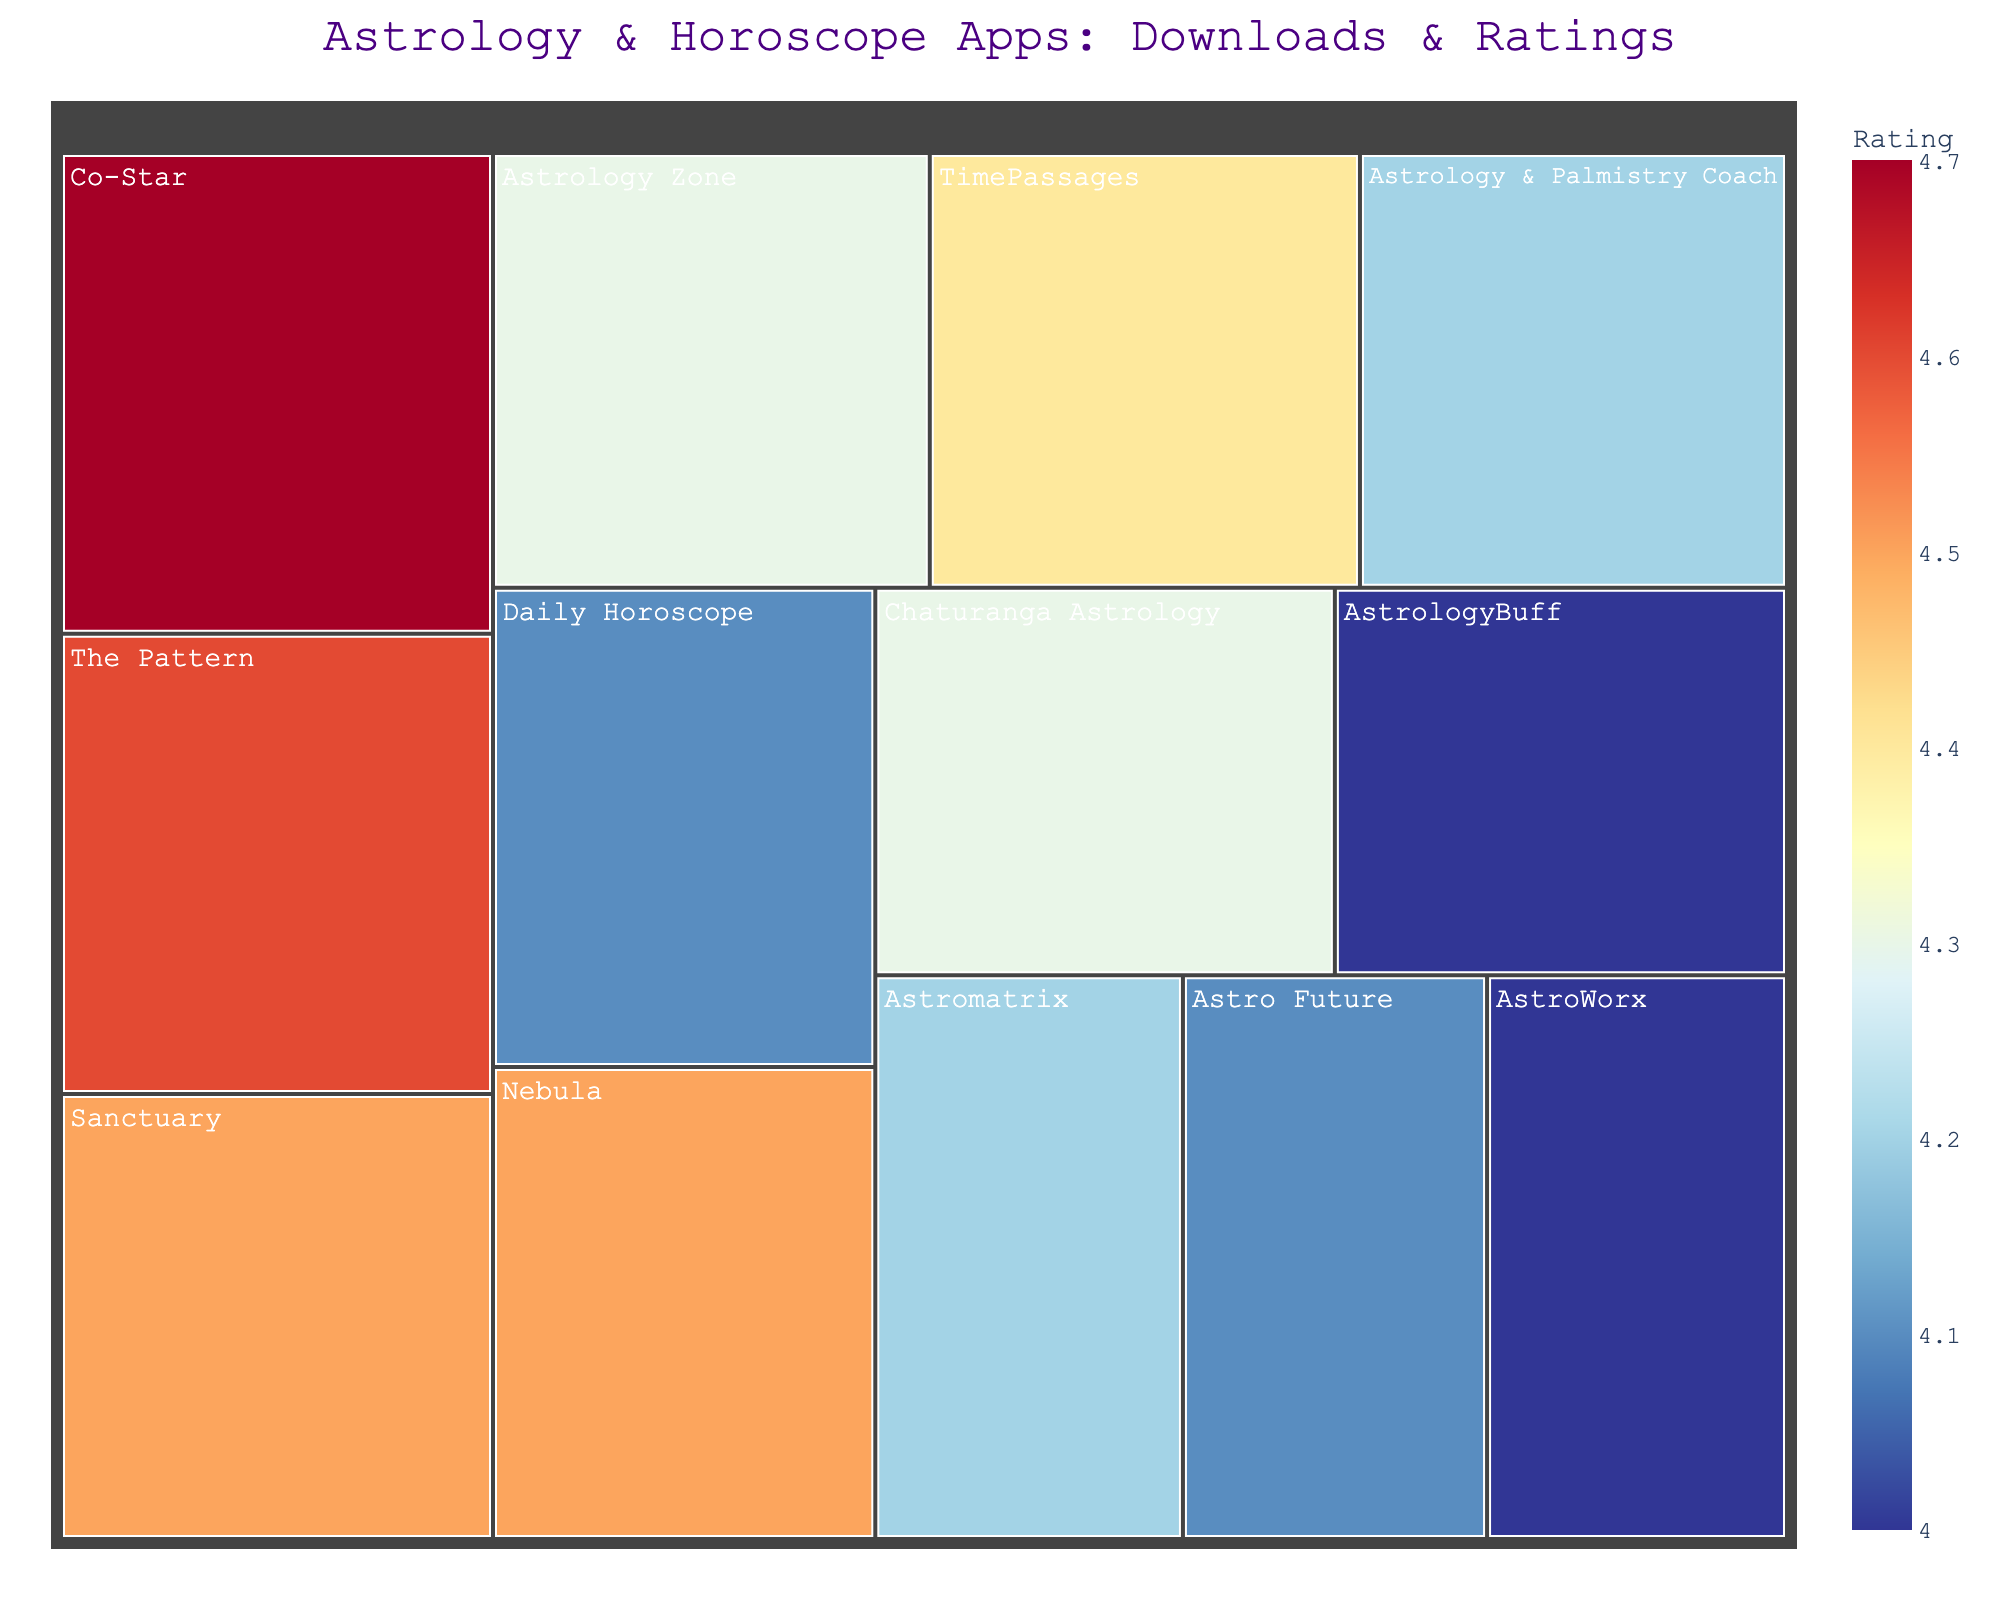Which app has the highest downloads? Look for the largest rectangle in the treemap, as size represents the number of downloads. The label should show this app's name.
Answer: Co-Star Which app has the highest rating? Examine the color scale to determine which app's rectangle is closest to the top of the color range (deep blue). Check the hover data if needed.
Answer: Co-Star Which app has the smallest number of downloads? Identify the smallest rectangle, size being an indicator of the number of downloads. The label on the smallest rectangle will show the app's name.
Answer: AstroWorx How many apps have a user rating of 4.5 or above? Mentally count all the rectangles that are in the higher end of the color scale (blue shades) and verify their exact ratings through hover data.
Answer: 3 Among the apps with ratings of 4.2, which has the highest downloads? Look for rectangles marked with a lighter shade corresponding to a 4.2 rating and compare their sizes to find the largest among them.
Answer: Astrology & Palmistry Coach How do the downloads of the app 'Astrology Zone' compare to 'AstroWorx'? Identify the corresponding rectangles for both apps and compare their sizes. 'Astrology Zone' should be significantly larger. Use hover data to compare exact numbers.
Answer: Astrology Zone has significantly more downloads Which two apps have the closest download counts? Scan the plot to find rectangles of approximately the same size. Verify their exact download counts through hover data.
Answer: Chaturanga Astrology and AstrologyBuff Which app has the highest rating among those with under a million downloads? Identify all the smaller rectangles (indicating less than a million downloads) and then note their color shades and exact ratings through hover data.
Answer: Nebula What is the downloaded-count range for apps with a rating of 4.0? Look for rectangles with the color corresponding to a 4.0 rating and compare their sizes. Verify the exact download counts through hover data.
Answer: 500,000 to 800,000 